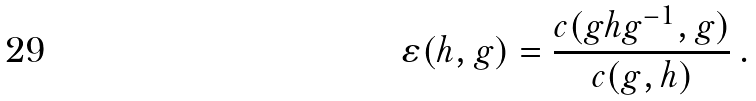Convert formula to latex. <formula><loc_0><loc_0><loc_500><loc_500>\varepsilon ( h , g ) = \frac { c ( g h g ^ { - 1 } , g ) } { c ( g , h ) } \, .</formula> 